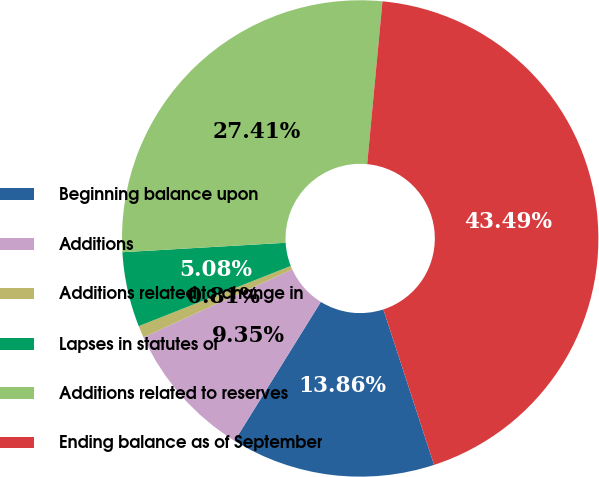Convert chart to OTSL. <chart><loc_0><loc_0><loc_500><loc_500><pie_chart><fcel>Beginning balance upon<fcel>Additions<fcel>Additions related to change in<fcel>Lapses in statutes of<fcel>Additions related to reserves<fcel>Ending balance as of September<nl><fcel>13.86%<fcel>9.35%<fcel>0.81%<fcel>5.08%<fcel>27.41%<fcel>43.49%<nl></chart> 